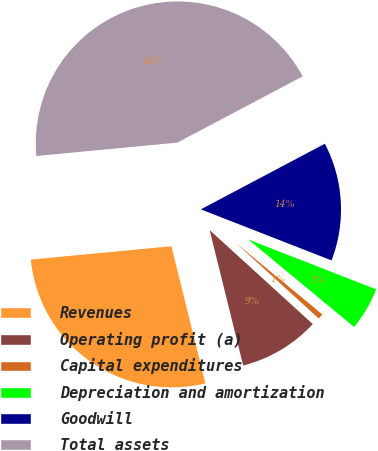<chart> <loc_0><loc_0><loc_500><loc_500><pie_chart><fcel>Revenues<fcel>Operating profit (a)<fcel>Capital expenditures<fcel>Depreciation and amortization<fcel>Goodwill<fcel>Total assets<nl><fcel>27.36%<fcel>9.37%<fcel>0.77%<fcel>5.07%<fcel>13.67%<fcel>43.76%<nl></chart> 